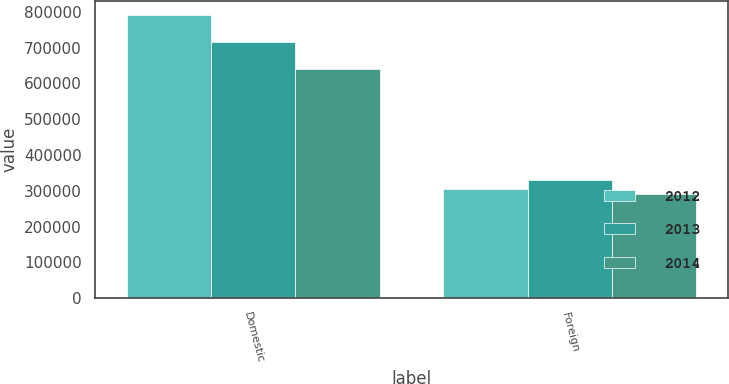Convert chart to OTSL. <chart><loc_0><loc_0><loc_500><loc_500><stacked_bar_chart><ecel><fcel>Domestic<fcel>Foreign<nl><fcel>2012<fcel>789689<fcel>304518<nl><fcel>2013<fcel>714723<fcel>331263<nl><fcel>2014<fcel>640896<fcel>290169<nl></chart> 